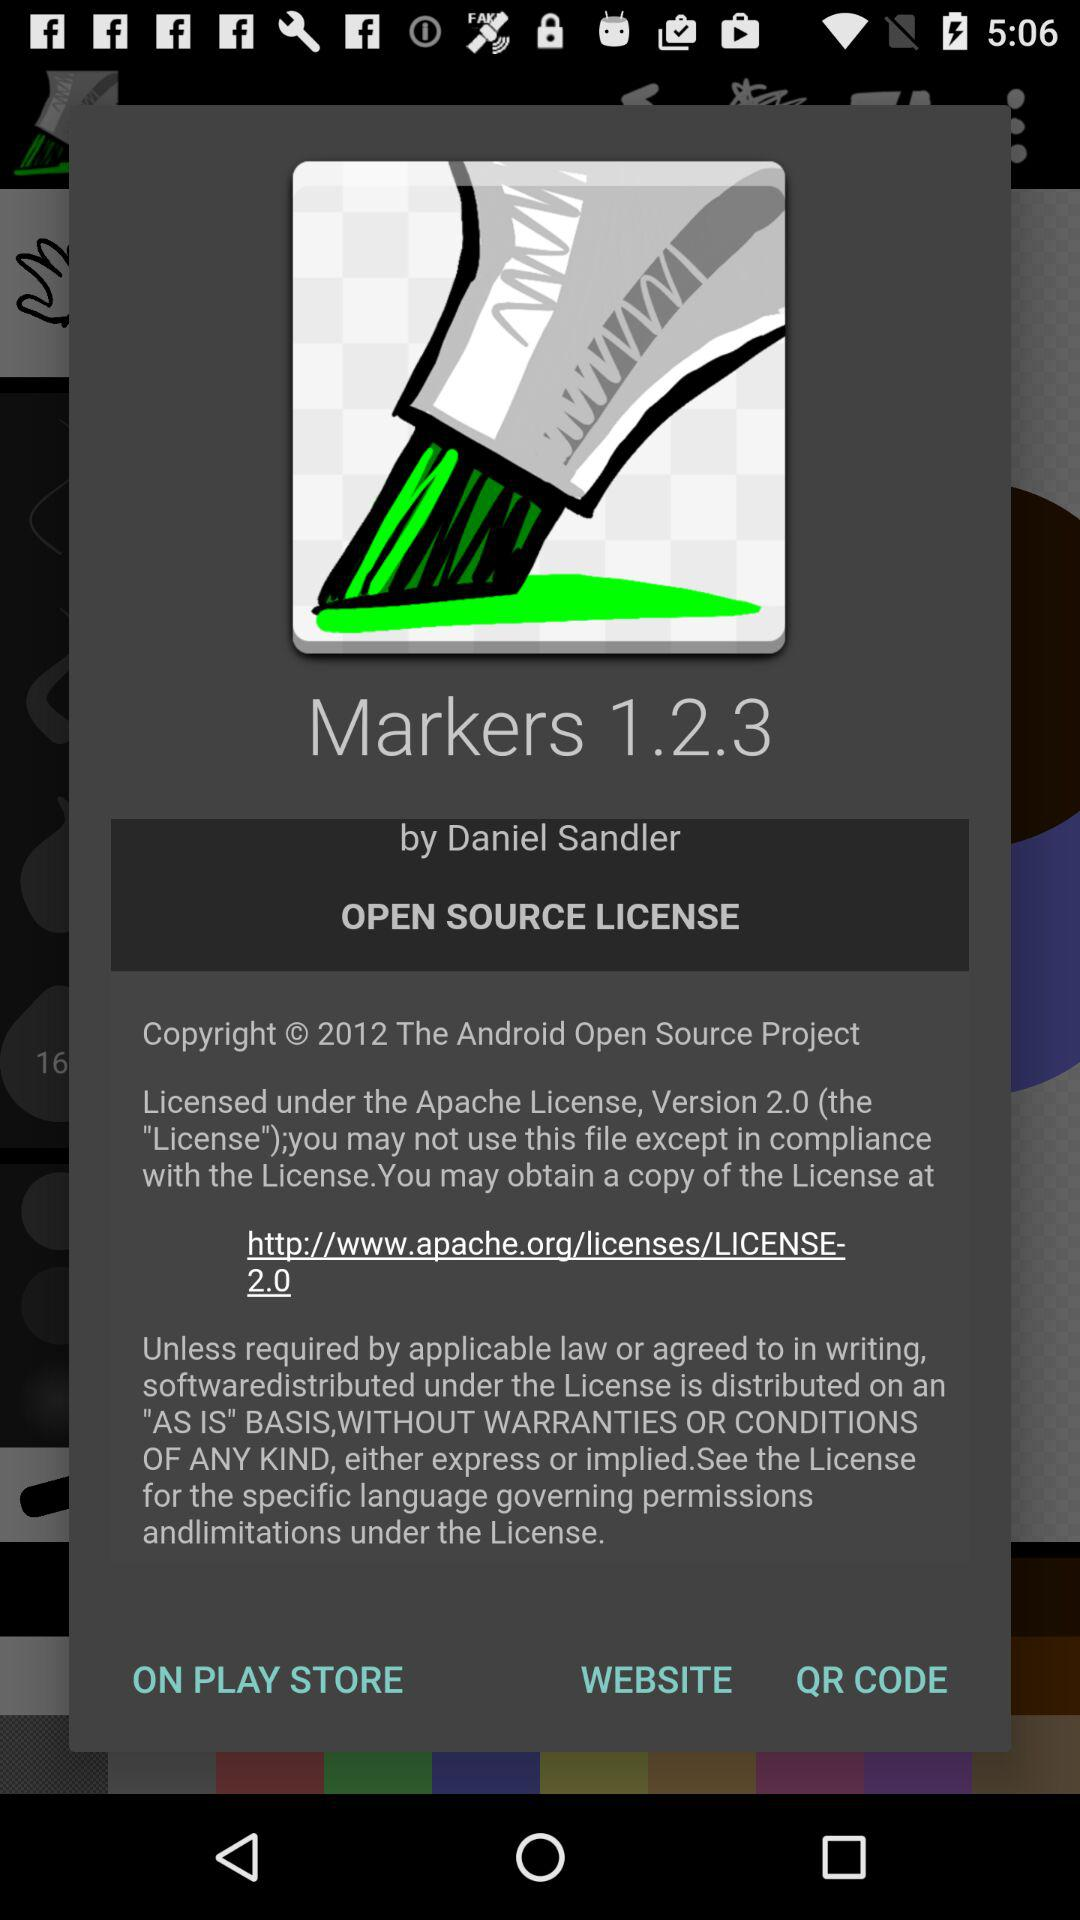What is the link for a copy of the license? The link for a copy of the license is http://www.apache.org/licenses/LICENSE-2.0. 